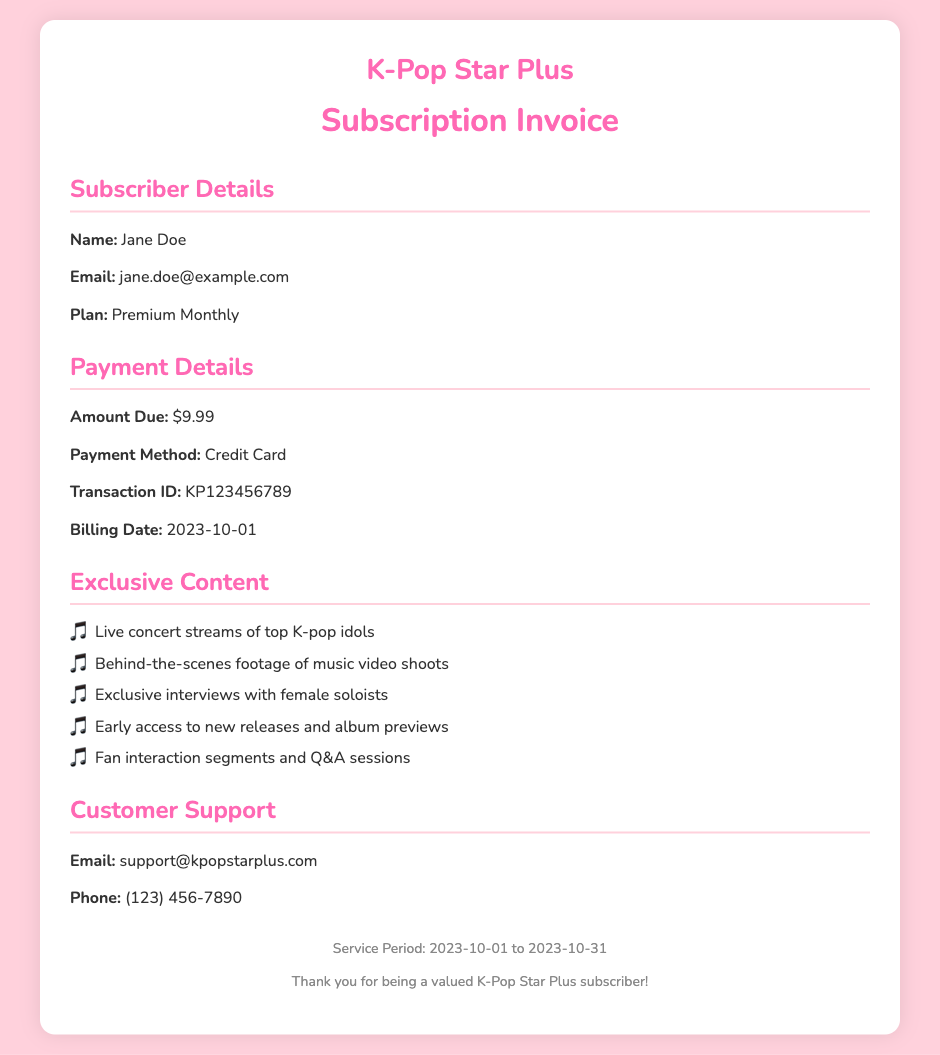What is the subscriber's name? The name of the subscriber is provided in the subscriber details section.
Answer: Jane Doe What is the amount due for the subscription? The payment details show the amount that needs to be paid for the subscription.
Answer: $9.99 What is the payment method used? The payment details specify the method through which the payment was made.
Answer: Credit Card What is the transaction ID associated with this invoice? The transaction ID is mentioned in the payment details for reference.
Answer: KP123456789 What is the service period for this subscription? The footer section of the document indicates the timeframe of service.
Answer: 2023-10-01 to 2023-10-31 Which type of subscription plan does the user have? The plan type is mentioned in the subscriber info section of the invoice.
Answer: Premium Monthly What exclusive content may subscribers access? The exclusive content list includes various types of K-pop content available to subscribers.
Answer: Live concert streams of top K-pop idols What is the email address for customer support? The customer support section provides an email address for contacting support.
Answer: support@kpopstarplus.com Who is featured in the exclusive interviews? The exclusive content details mention the subjects of the interviews available to subscribers.
Answer: female soloists 